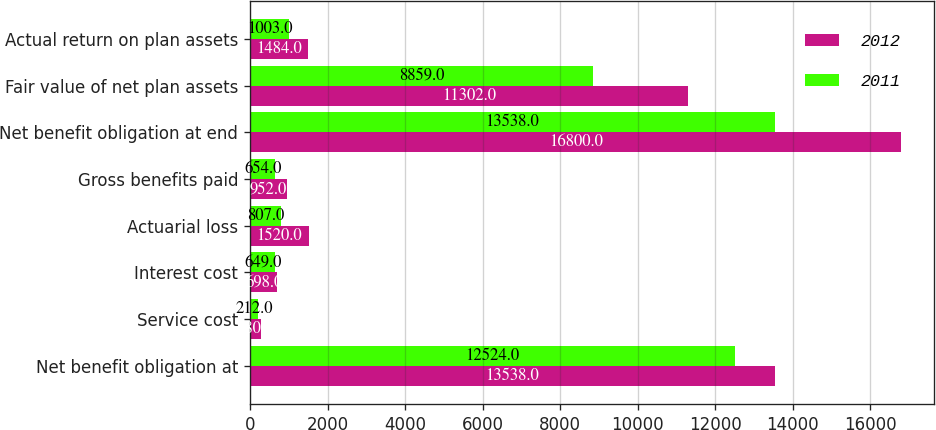Convert chart to OTSL. <chart><loc_0><loc_0><loc_500><loc_500><stacked_bar_chart><ecel><fcel>Net benefit obligation at<fcel>Service cost<fcel>Interest cost<fcel>Actuarial loss<fcel>Gross benefits paid<fcel>Net benefit obligation at end<fcel>Fair value of net plan assets<fcel>Actual return on plan assets<nl><fcel>2012<fcel>13538<fcel>280<fcel>698<fcel>1520<fcel>952<fcel>16800<fcel>11302<fcel>1484<nl><fcel>2011<fcel>12524<fcel>212<fcel>649<fcel>807<fcel>654<fcel>13538<fcel>8859<fcel>1003<nl></chart> 